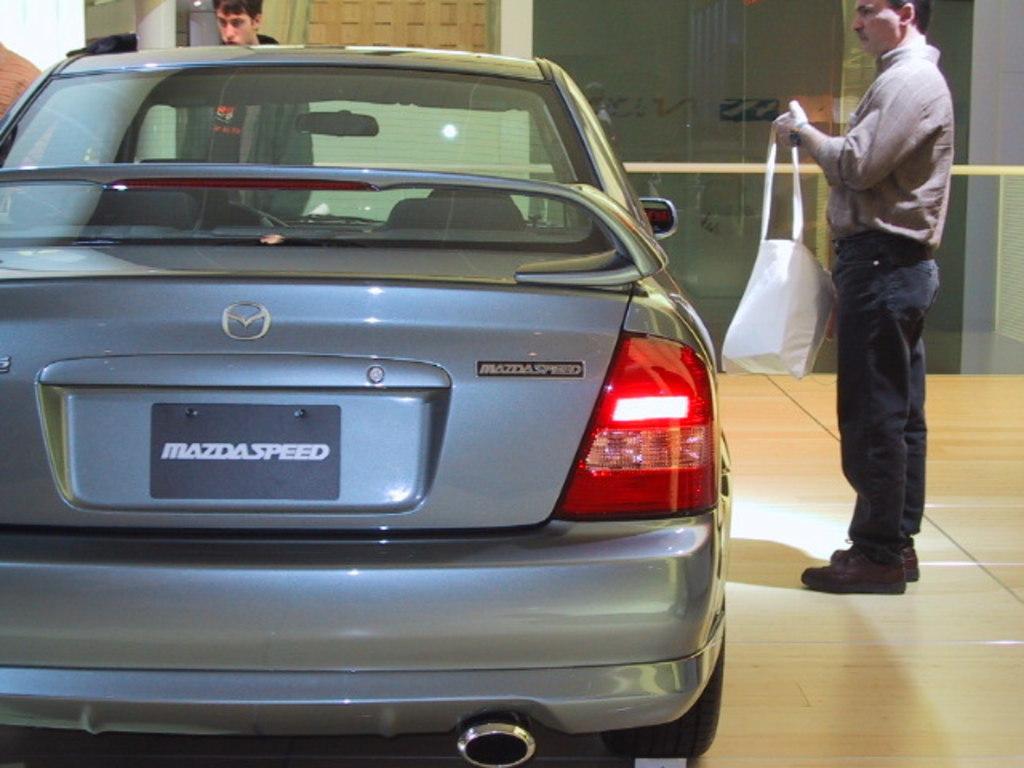Could you give a brief overview of what you see in this image? In this image there is a car at left side of this image. There is one person standing at right side of this image is holding a bag ,and there is one another person is at top left side of this image, and there is a building in the background. 